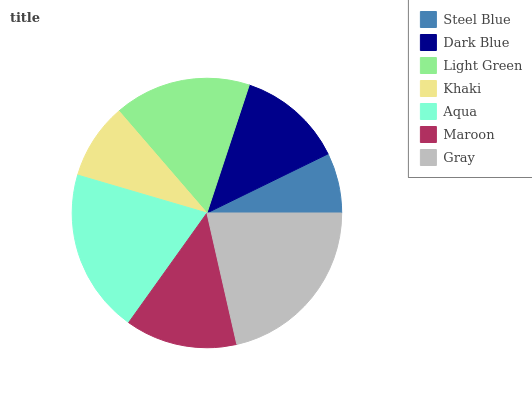Is Steel Blue the minimum?
Answer yes or no. Yes. Is Gray the maximum?
Answer yes or no. Yes. Is Dark Blue the minimum?
Answer yes or no. No. Is Dark Blue the maximum?
Answer yes or no. No. Is Dark Blue greater than Steel Blue?
Answer yes or no. Yes. Is Steel Blue less than Dark Blue?
Answer yes or no. Yes. Is Steel Blue greater than Dark Blue?
Answer yes or no. No. Is Dark Blue less than Steel Blue?
Answer yes or no. No. Is Maroon the high median?
Answer yes or no. Yes. Is Maroon the low median?
Answer yes or no. Yes. Is Gray the high median?
Answer yes or no. No. Is Aqua the low median?
Answer yes or no. No. 